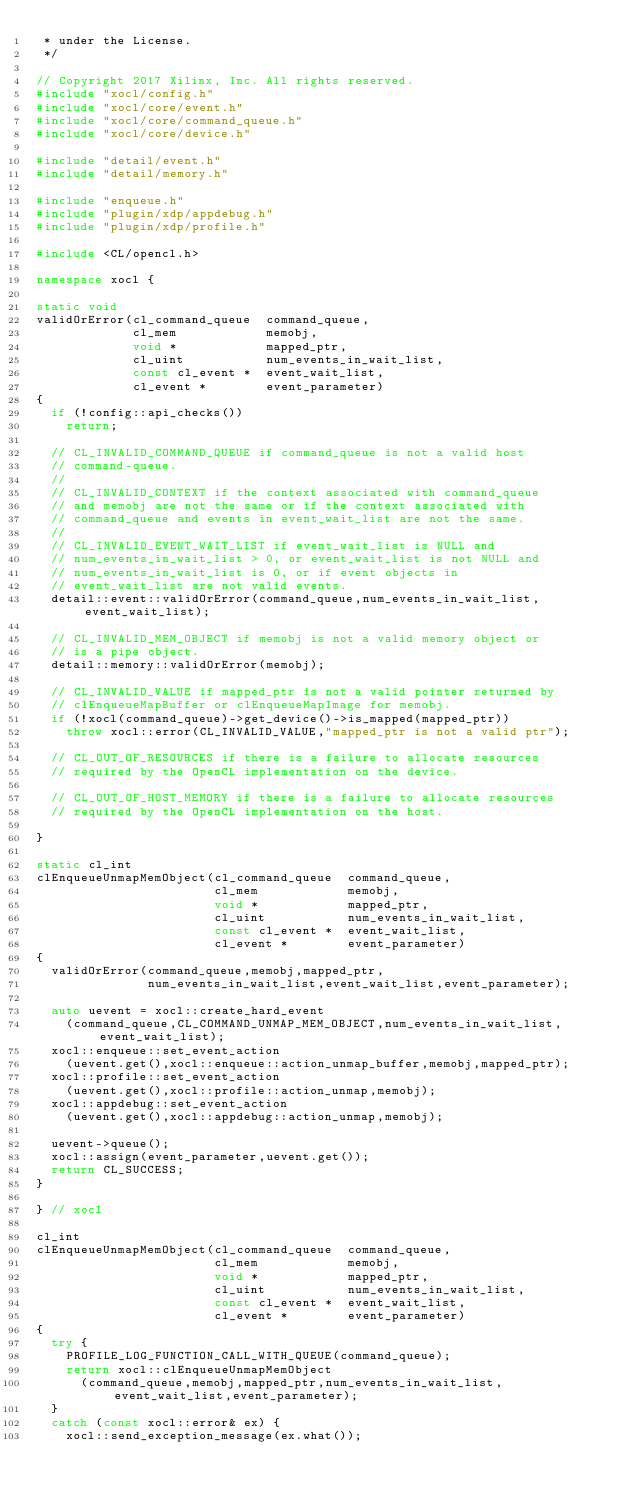Convert code to text. <code><loc_0><loc_0><loc_500><loc_500><_C++_> * under the License.
 */

// Copyright 2017 Xilinx, Inc. All rights reserved.
#include "xocl/config.h"
#include "xocl/core/event.h"
#include "xocl/core/command_queue.h"
#include "xocl/core/device.h"

#include "detail/event.h"
#include "detail/memory.h"

#include "enqueue.h"
#include "plugin/xdp/appdebug.h"
#include "plugin/xdp/profile.h"

#include <CL/opencl.h>

namespace xocl {

static void
validOrError(cl_command_queue  command_queue,
             cl_mem            memobj,
             void *            mapped_ptr,
             cl_uint           num_events_in_wait_list,
             const cl_event *  event_wait_list,
             cl_event *        event_parameter)
{
  if (!config::api_checks())
    return;

  // CL_INVALID_COMMAND_QUEUE if command_queue is not a valid host
  // command-queue.
  //
  // CL_INVALID_CONTEXT if the context associated with command_queue
  // and memobj are not the same or if the context associated with
  // command_queue and events in event_wait_list are not the same.
  //
  // CL_INVALID_EVENT_WAIT_LIST if event_wait_list is NULL and
  // num_events_in_wait_list > 0, or event_wait_list is not NULL and
  // num_events_in_wait_list is 0, or if event objects in
  // event_wait_list are not valid events.
  detail::event::validOrError(command_queue,num_events_in_wait_list,event_wait_list);

  // CL_INVALID_MEM_OBJECT if memobj is not a valid memory object or
  // is a pipe object.
  detail::memory::validOrError(memobj);

  // CL_INVALID_VALUE if mapped_ptr is not a valid pointer returned by
  // clEnqueueMapBuffer or clEnqueueMapImage for memobj.
  if (!xocl(command_queue)->get_device()->is_mapped(mapped_ptr))
    throw xocl::error(CL_INVALID_VALUE,"mapped_ptr is not a valid ptr");

  // CL_OUT_OF_RESOURCES if there is a failure to allocate resources
  // required by the OpenCL implementation on the device.

  // CL_OUT_OF_HOST_MEMORY if there is a failure to allocate resources
  // required by the OpenCL implementation on the host.

}

static cl_int
clEnqueueUnmapMemObject(cl_command_queue  command_queue,
                        cl_mem            memobj,
                        void *            mapped_ptr,
                        cl_uint           num_events_in_wait_list,
                        const cl_event *  event_wait_list,
                        cl_event *        event_parameter)
{
  validOrError(command_queue,memobj,mapped_ptr,
               num_events_in_wait_list,event_wait_list,event_parameter);

  auto uevent = xocl::create_hard_event
    (command_queue,CL_COMMAND_UNMAP_MEM_OBJECT,num_events_in_wait_list,event_wait_list);
  xocl::enqueue::set_event_action
    (uevent.get(),xocl::enqueue::action_unmap_buffer,memobj,mapped_ptr);
  xocl::profile::set_event_action
    (uevent.get(),xocl::profile::action_unmap,memobj);
  xocl::appdebug::set_event_action
    (uevent.get(),xocl::appdebug::action_unmap,memobj);

  uevent->queue();
  xocl::assign(event_parameter,uevent.get());
  return CL_SUCCESS;
}

} // xocl

cl_int
clEnqueueUnmapMemObject(cl_command_queue  command_queue,
                        cl_mem            memobj,
                        void *            mapped_ptr,
                        cl_uint           num_events_in_wait_list,
                        const cl_event *  event_wait_list,
                        cl_event *        event_parameter)
{
  try {
    PROFILE_LOG_FUNCTION_CALL_WITH_QUEUE(command_queue);
    return xocl::clEnqueueUnmapMemObject
      (command_queue,memobj,mapped_ptr,num_events_in_wait_list,event_wait_list,event_parameter);
  }
  catch (const xocl::error& ex) {
    xocl::send_exception_message(ex.what());</code> 